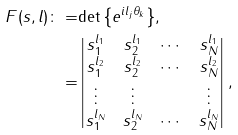Convert formula to latex. <formula><loc_0><loc_0><loc_500><loc_500>F ( s , l ) \colon = & { \det \left \{ e ^ { i l _ { j } \theta _ { k } } \right \} } , \\ = & \begin{vmatrix} s _ { 1 } ^ { l _ { 1 } } & s _ { 2 } ^ { l _ { 1 } } & \cdots & s _ { N } ^ { l _ { 1 } } \\ s _ { 1 } ^ { l _ { 2 } } & s _ { 2 } ^ { l _ { 2 } } & \cdots & s _ { N } ^ { l _ { 2 } } \\ \vdots & \vdots & & \vdots \\ s _ { 1 } ^ { l _ { N } } & s _ { 2 } ^ { l _ { N } } & \cdots & s _ { N } ^ { l _ { N } } \end{vmatrix} ,</formula> 